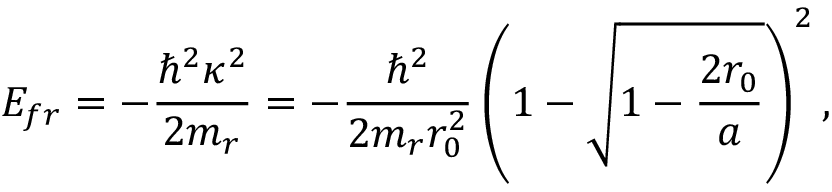<formula> <loc_0><loc_0><loc_500><loc_500>E _ { f r } = - \frac { \hbar { ^ } { 2 } \kappa ^ { 2 } } { 2 m _ { r } } = - \frac { \hbar { ^ } { 2 } } { 2 m _ { r } r _ { 0 } ^ { 2 } } \left ( 1 - \sqrt { 1 - \frac { 2 r _ { 0 } } { a } } \right ) ^ { 2 } ,</formula> 